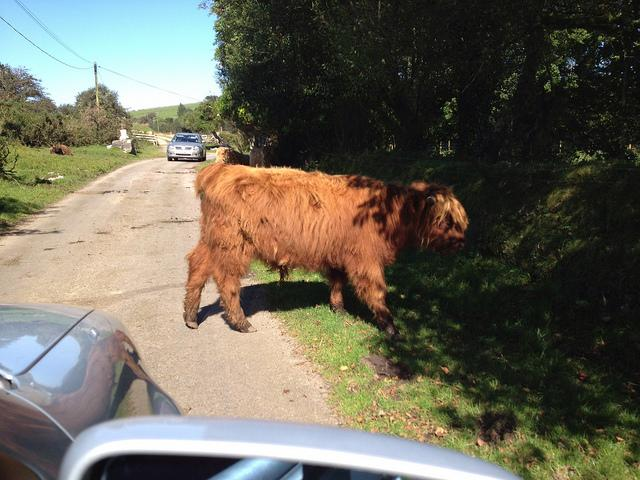What type of animal is shown? Please explain your reasoning. wild. He is roaming free. 